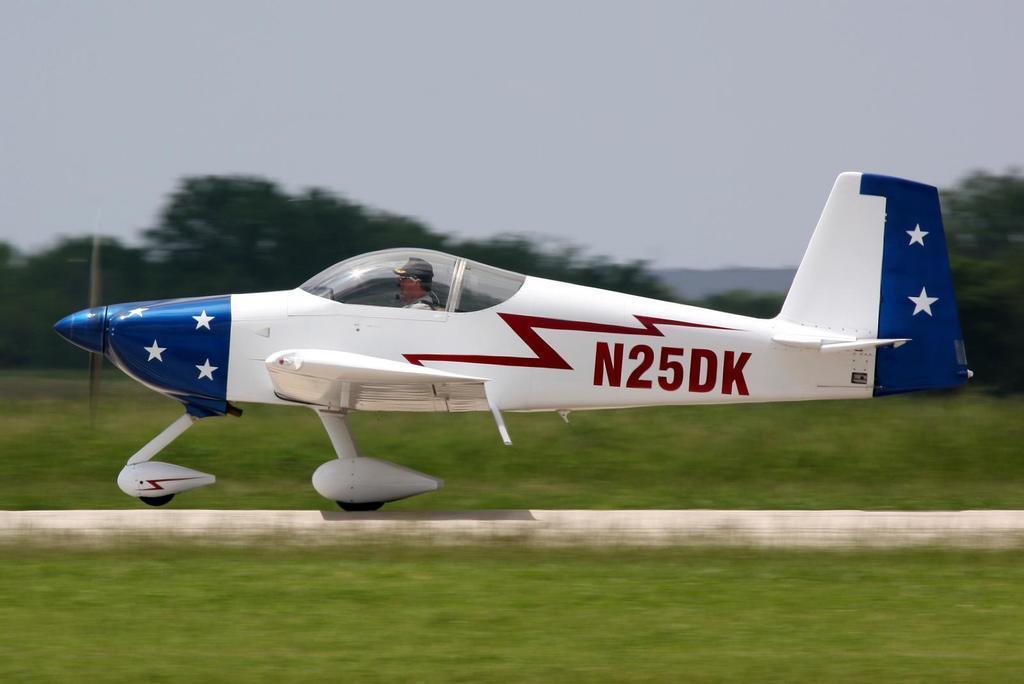In one or two sentences, can you explain what this image depicts? This picture is clicked outside. In the foreground we can see the green grass and the tramp. In the center there is a person seems to be riding an aircraft and we can see the text on the aircraft. In the background there is the sky and we can see the trees. 